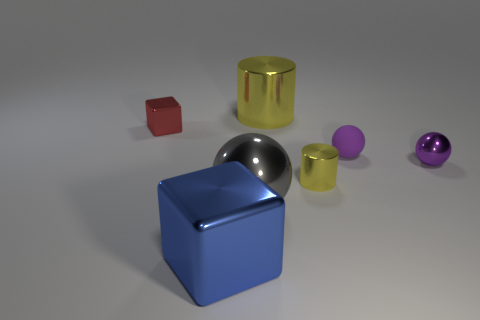There is a object that is behind the red metal cube; is it the same size as the small metal sphere?
Provide a short and direct response. No. What number of objects are tiny metal objects or small purple metallic objects?
Keep it short and to the point. 3. The big shiny thing that is the same color as the tiny cylinder is what shape?
Provide a short and direct response. Cylinder. What size is the metal object that is in front of the small yellow thing and behind the large block?
Your response must be concise. Large. How many things are there?
Keep it short and to the point. 7. What number of blocks are either blue things or big gray shiny things?
Provide a short and direct response. 1. What number of shiny cubes are in front of the tiny purple metal thing that is in front of the yellow cylinder on the left side of the small cylinder?
Offer a terse response. 1. The cylinder that is the same size as the gray shiny sphere is what color?
Ensure brevity in your answer.  Yellow. How many other things are there of the same color as the tiny metallic cylinder?
Your response must be concise. 1. Are there more balls that are left of the small metal block than small brown matte cylinders?
Your response must be concise. No. 